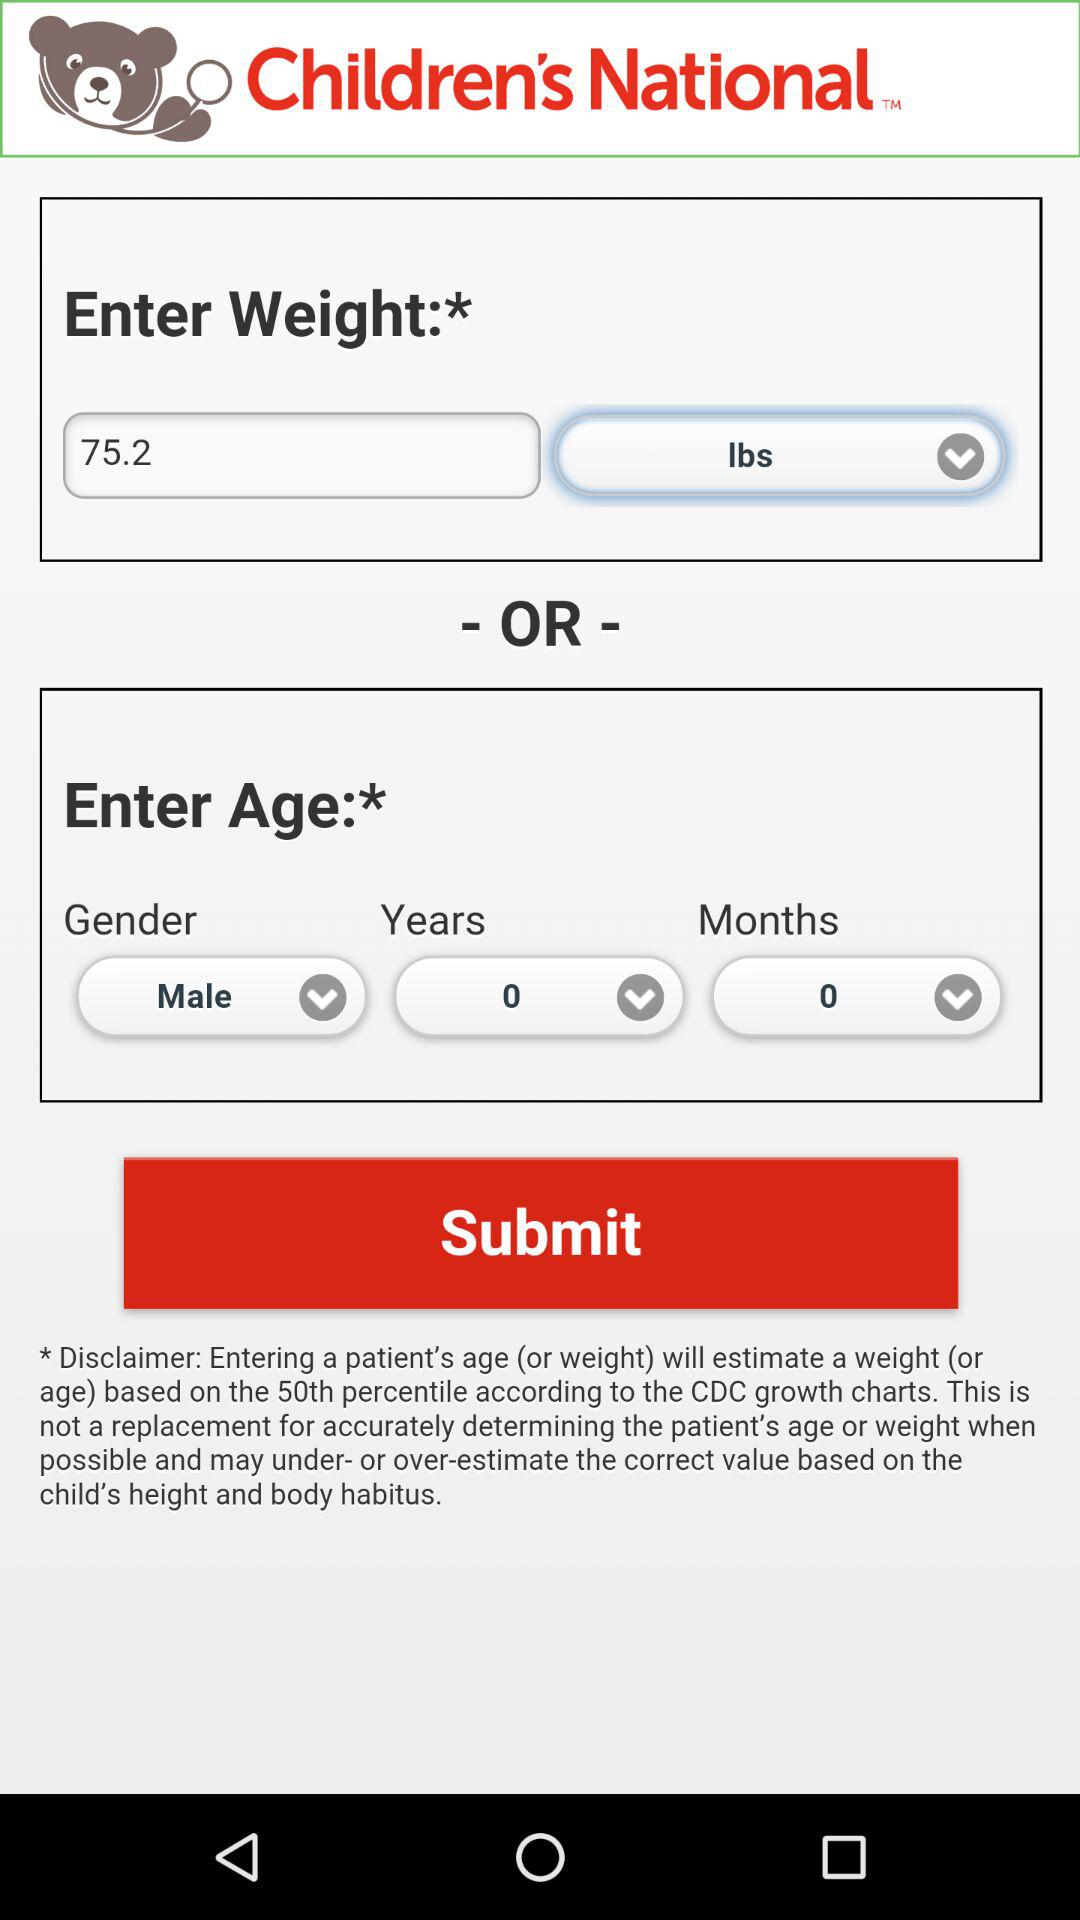What is the weight? The weight is 75.2 lbs. 